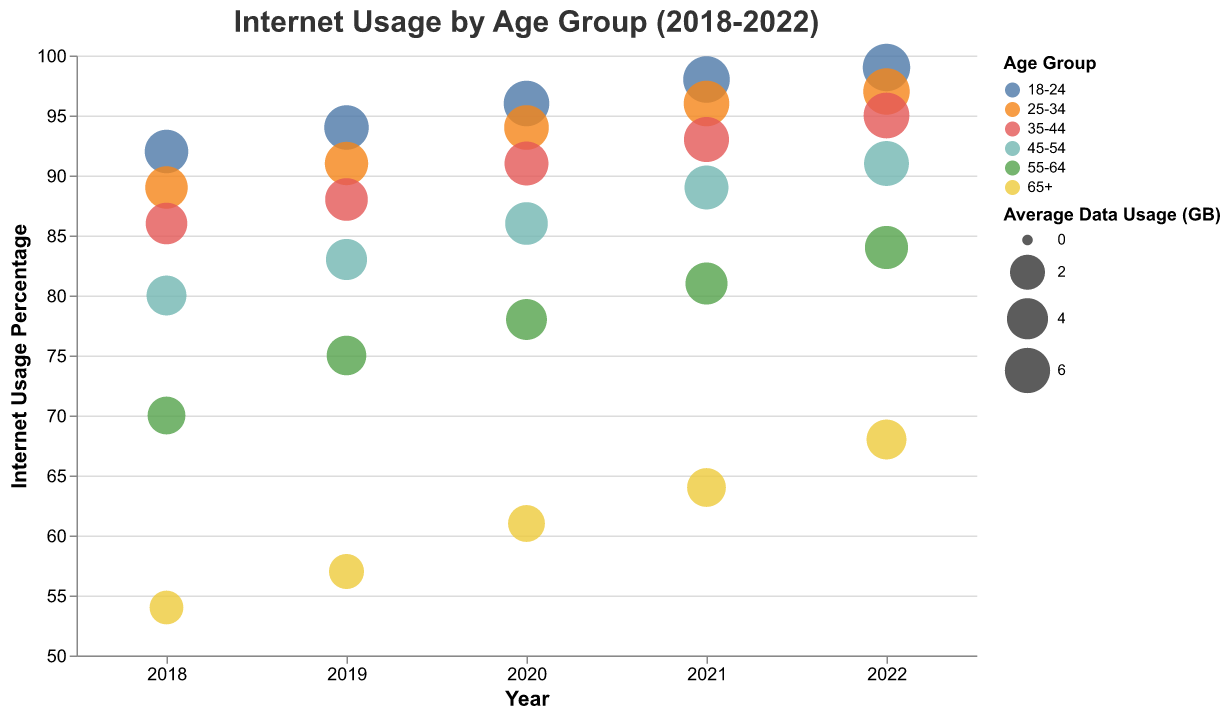What is the internet usage percentage for the 18-24 age group in 2020? Look at the y-axis which denotes internet usage percentage and follow the corresponding bubble for the 18-24 age group in 2020
Answer: 96 Which age group had the highest average data usage in 2022? Observe the size of the bubbles, which indicate average data usage, for each age group in 2022. The largest bubble represents the highest average data usage.
Answer: 18-24 How did the internet usage percentage for the 65+ age group change from 2019 to 2020? Look at the y-values associated with the 65+ age group for both 2019 and 2020 and subtract the value for 2019 from the value for 2020
Answer: 4% increase Compare the internet usage percentages for the 25-34 age group between 2018 and 2021. Which year had higher usage? Find the 25-34 age group bubbles for 2018 and 2021, compare their y-values to see which is higher
Answer: 2021 Which year shows the largest bubble for the 45-54 age group? Look for the 45-54 age group bubbles across all years and identify the year where the bubble size is the largest
Answer: 2022 What is the trend in internet usage percentage for the 55-64 age group from 2018 to 2022? Observe the y-values for the 55-64 age group from 2018 to 2022 and describe whether they are increasing, decreasing, or stable
Answer: Increasing What is the average internet usage percentage for the 35-44 age group over the years 2018 to 2022? Sum the internet usage percentages for the 35-44 age group from 2018 to 2022 and divide by the number of years (5) to get the average
Answer: 90.6% By how much did the average data usage for the 25-34 age group change from 2018 to 2022? Subtract the average data usage in 2018 from the average data usage in 2022 for the 25-34 age group
Answer: 2.1 GB increase Was there any age group with a declining internet usage percentage from 2021 to 2022? Compare the internet usage percentages for each age group between 2021 and 2022 to see if any have decreased
Answer: No 